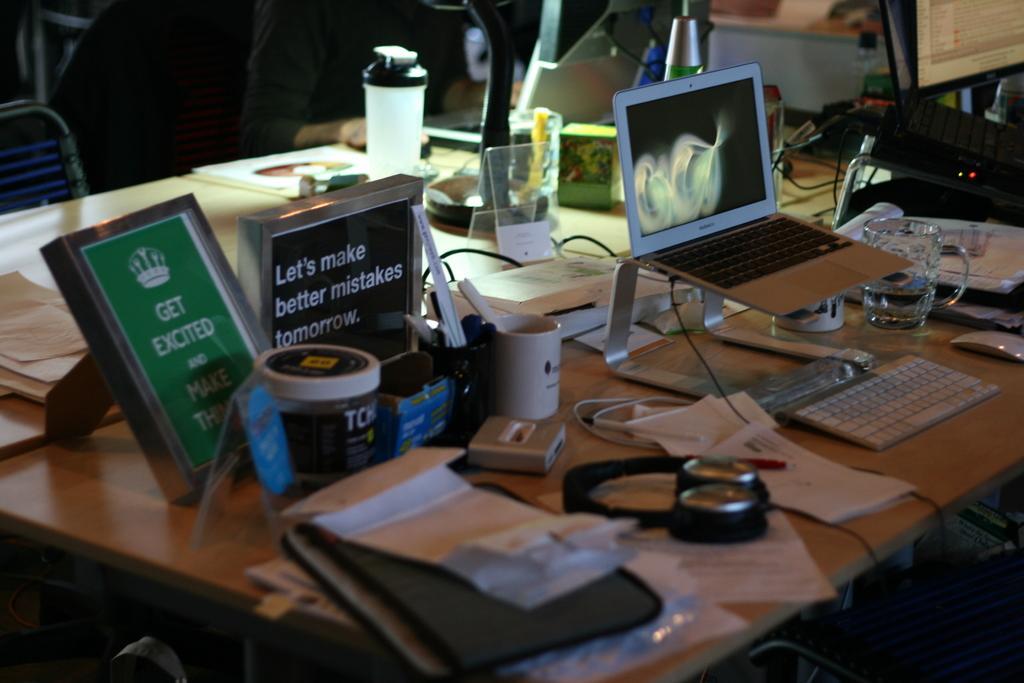How would you summarize this image in a sentence or two? In this image, there is an inside view of a room. There is a person sitting in front of the table. This table contains bottles, cups, glass, laptops, headset and some papers. 